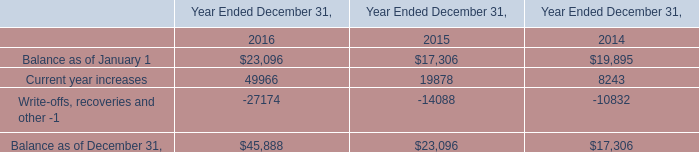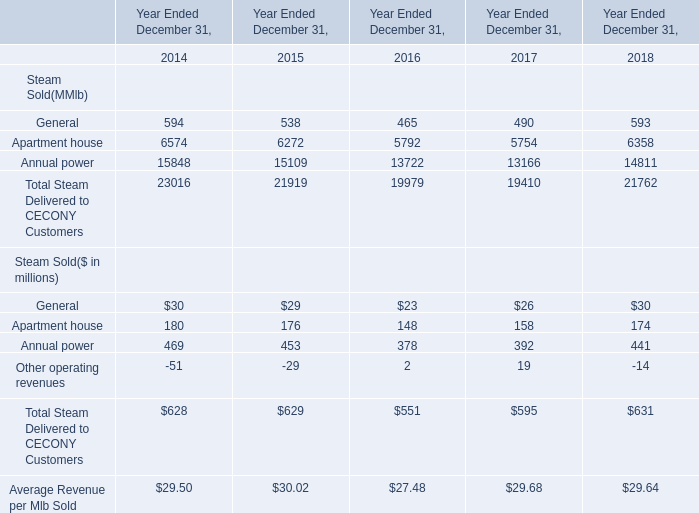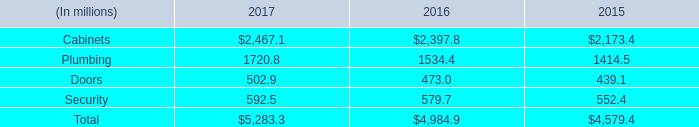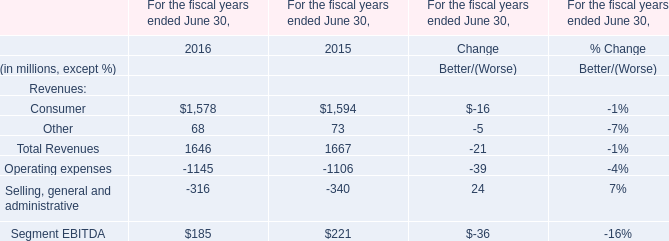in 2017 what was amount net sales applicable to international market in millions 
Computations: (25% * 5283.3)
Answer: 1320.825. 